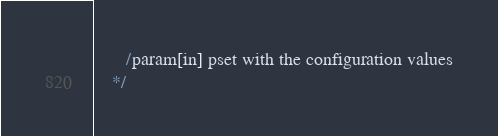Convert code to text. <code><loc_0><loc_0><loc_500><loc_500><_C_>
       /param[in] pset with the configuration values
    */</code> 